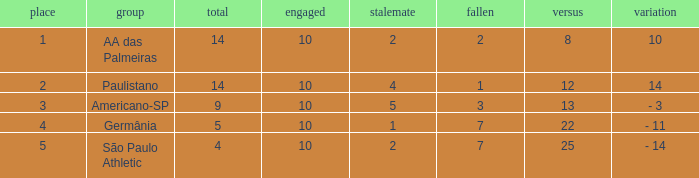What team has an against more than 8, lost of 7, and the position is 5? São Paulo Athletic. 